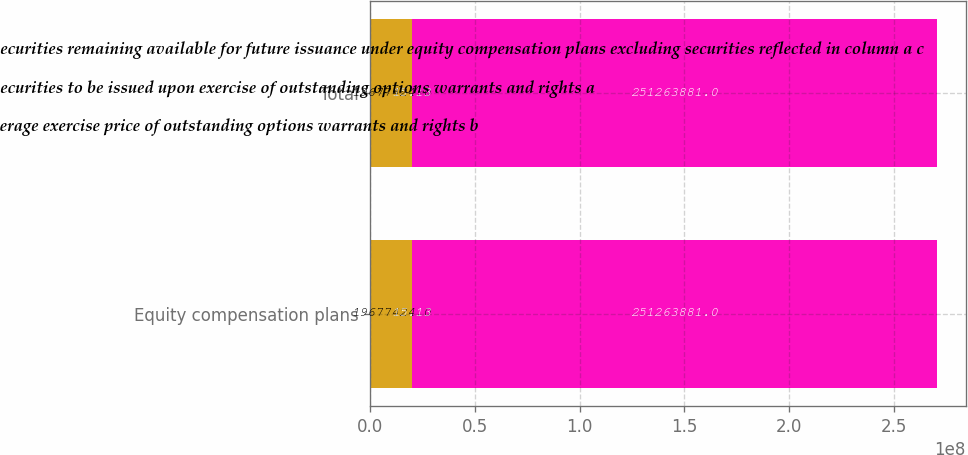<chart> <loc_0><loc_0><loc_500><loc_500><stacked_bar_chart><ecel><fcel>Equity compensation plans<fcel>Total<nl><fcel>Number of securities remaining available for future issuance under equity compensation plans excluding securities reflected in column a c<fcel>1.96774e+07<fcel>1.96774e+07<nl><fcel>Number of securities to be issued upon exercise of outstanding options warrants and rights a<fcel>15.13<fcel>15.13<nl><fcel>Weightedaverage exercise price of outstanding options warrants and rights b<fcel>2.51264e+08<fcel>2.51264e+08<nl></chart> 